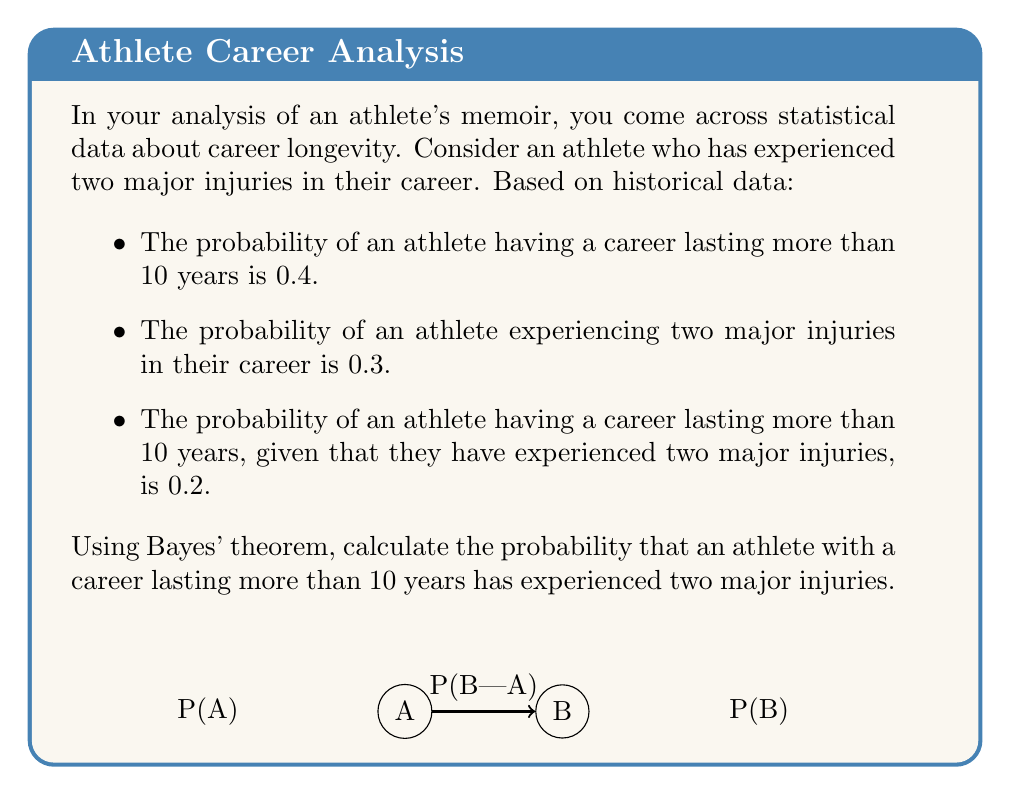Can you answer this question? Let's approach this step-by-step using Bayes' theorem:

1) Define our events:
   A: Career lasting more than 10 years
   B: Experiencing two major injuries

2) We're given:
   P(A) = 0.4 (probability of career > 10 years)
   P(B) = 0.3 (probability of two major injuries)
   P(A|B) = 0.2 (probability of career > 10 years given two major injuries)

3) We want to find P(B|A), which is the probability of having two major injuries given a career > 10 years.

4) Bayes' theorem states:

   $$P(B|A) = \frac{P(A|B) \cdot P(B)}{P(A)}$$

5) Substituting our known values:

   $$P(B|A) = \frac{0.2 \cdot 0.3}{0.4}$$

6) Calculating:
   
   $$P(B|A) = \frac{0.06}{0.4} = 0.15$$

Therefore, the probability that an athlete with a career lasting more than 10 years has experienced two major injuries is 0.15 or 15%.
Answer: 0.15 